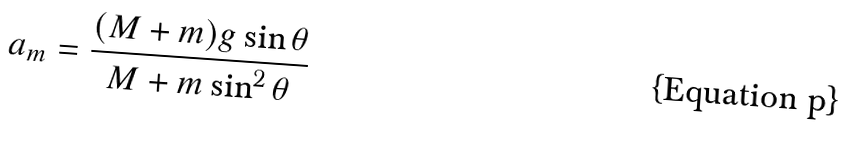Convert formula to latex. <formula><loc_0><loc_0><loc_500><loc_500>a _ { m } = \frac { ( M + m ) g \sin \theta } { M + m \sin ^ { 2 } \theta }</formula> 